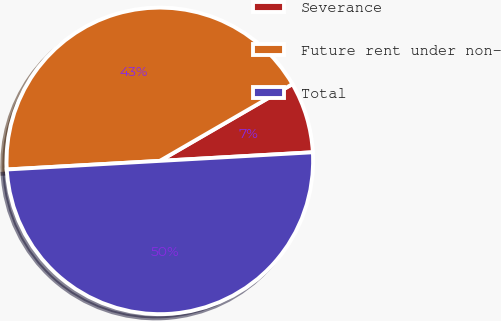Convert chart to OTSL. <chart><loc_0><loc_0><loc_500><loc_500><pie_chart><fcel>Severance<fcel>Future rent under non-<fcel>Total<nl><fcel>7.46%<fcel>42.54%<fcel>50.0%<nl></chart> 